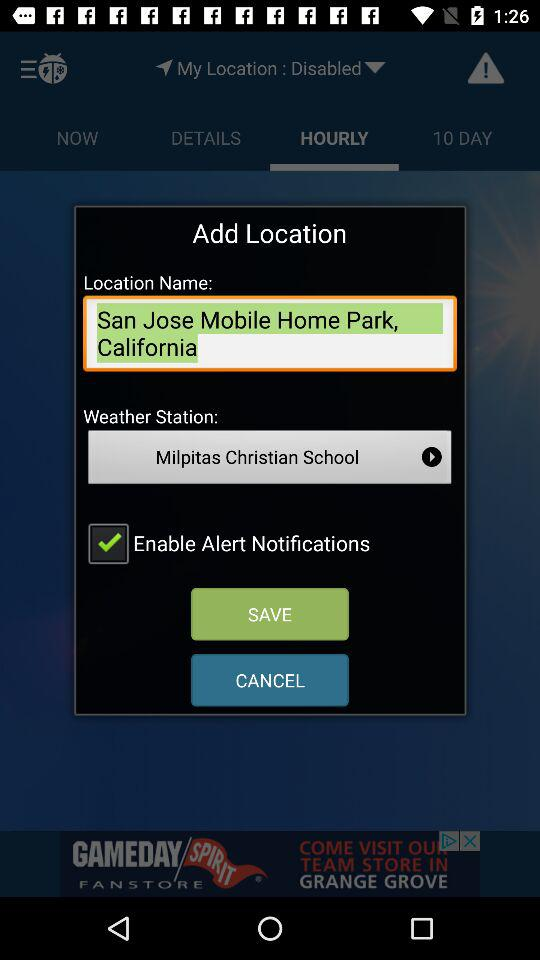What is the status of "Enable Alert Notifications"? The status is "on". 